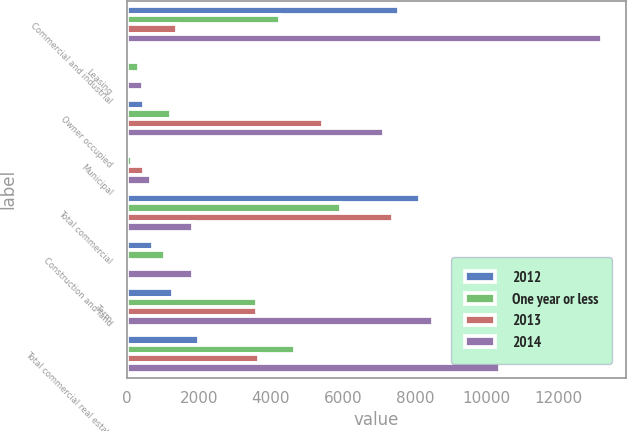Convert chart to OTSL. <chart><loc_0><loc_0><loc_500><loc_500><stacked_bar_chart><ecel><fcel>Commercial and industrial<fcel>Leasing<fcel>Owner occupied<fcel>Municipal<fcel>Total commercial<fcel>Construction and land<fcel>Term<fcel>Total commercial real estate<nl><fcel>2012<fcel>7560<fcel>29<fcel>467<fcel>85<fcel>8141<fcel>711<fcel>1292<fcel>2003<nl><fcel>One year or less<fcel>4267<fcel>323<fcel>1231<fcel>127<fcel>5948<fcel>1055<fcel>3619<fcel>4674<nl><fcel>2013<fcel>1384<fcel>90<fcel>5452<fcel>464<fcel>7390<fcel>76<fcel>3603<fcel>3679<nl><fcel>2014<fcel>13211<fcel>442<fcel>7150<fcel>676<fcel>1842<fcel>1842<fcel>8514<fcel>10356<nl></chart> 